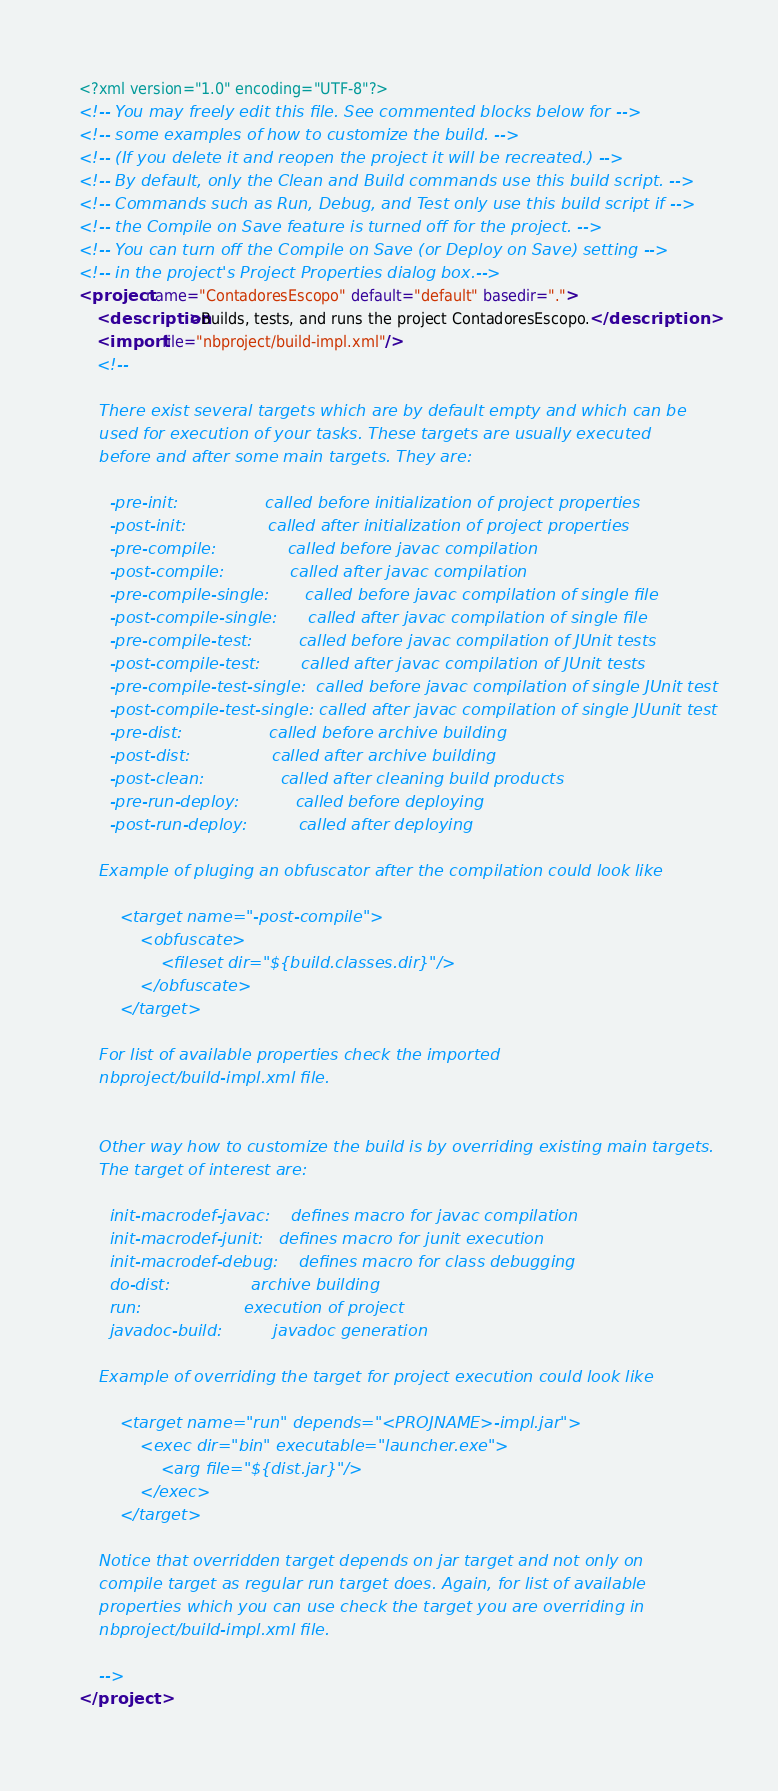Convert code to text. <code><loc_0><loc_0><loc_500><loc_500><_XML_><?xml version="1.0" encoding="UTF-8"?>
<!-- You may freely edit this file. See commented blocks below for -->
<!-- some examples of how to customize the build. -->
<!-- (If you delete it and reopen the project it will be recreated.) -->
<!-- By default, only the Clean and Build commands use this build script. -->
<!-- Commands such as Run, Debug, and Test only use this build script if -->
<!-- the Compile on Save feature is turned off for the project. -->
<!-- You can turn off the Compile on Save (or Deploy on Save) setting -->
<!-- in the project's Project Properties dialog box.-->
<project name="ContadoresEscopo" default="default" basedir=".">
    <description>Builds, tests, and runs the project ContadoresEscopo.</description>
    <import file="nbproject/build-impl.xml"/>
    <!--

    There exist several targets which are by default empty and which can be 
    used for execution of your tasks. These targets are usually executed 
    before and after some main targets. They are: 

      -pre-init:                 called before initialization of project properties 
      -post-init:                called after initialization of project properties 
      -pre-compile:              called before javac compilation 
      -post-compile:             called after javac compilation 
      -pre-compile-single:       called before javac compilation of single file
      -post-compile-single:      called after javac compilation of single file
      -pre-compile-test:         called before javac compilation of JUnit tests
      -post-compile-test:        called after javac compilation of JUnit tests
      -pre-compile-test-single:  called before javac compilation of single JUnit test
      -post-compile-test-single: called after javac compilation of single JUunit test
      -pre-dist:                 called before archive building 
      -post-dist:                called after archive building 
      -post-clean:               called after cleaning build products 
      -pre-run-deploy:           called before deploying
      -post-run-deploy:          called after deploying

    Example of pluging an obfuscator after the compilation could look like 

        <target name="-post-compile">
            <obfuscate>
                <fileset dir="${build.classes.dir}"/>
            </obfuscate>
        </target>

    For list of available properties check the imported 
    nbproject/build-impl.xml file. 


    Other way how to customize the build is by overriding existing main targets.
    The target of interest are: 

      init-macrodef-javac:    defines macro for javac compilation
      init-macrodef-junit:   defines macro for junit execution
      init-macrodef-debug:    defines macro for class debugging
      do-dist:                archive building
      run:                    execution of project 
      javadoc-build:          javadoc generation 

    Example of overriding the target for project execution could look like 

        <target name="run" depends="<PROJNAME>-impl.jar">
            <exec dir="bin" executable="launcher.exe">
                <arg file="${dist.jar}"/>
            </exec>
        </target>

    Notice that overridden target depends on jar target and not only on 
    compile target as regular run target does. Again, for list of available 
    properties which you can use check the target you are overriding in 
    nbproject/build-impl.xml file. 

    -->
</project>
</code> 